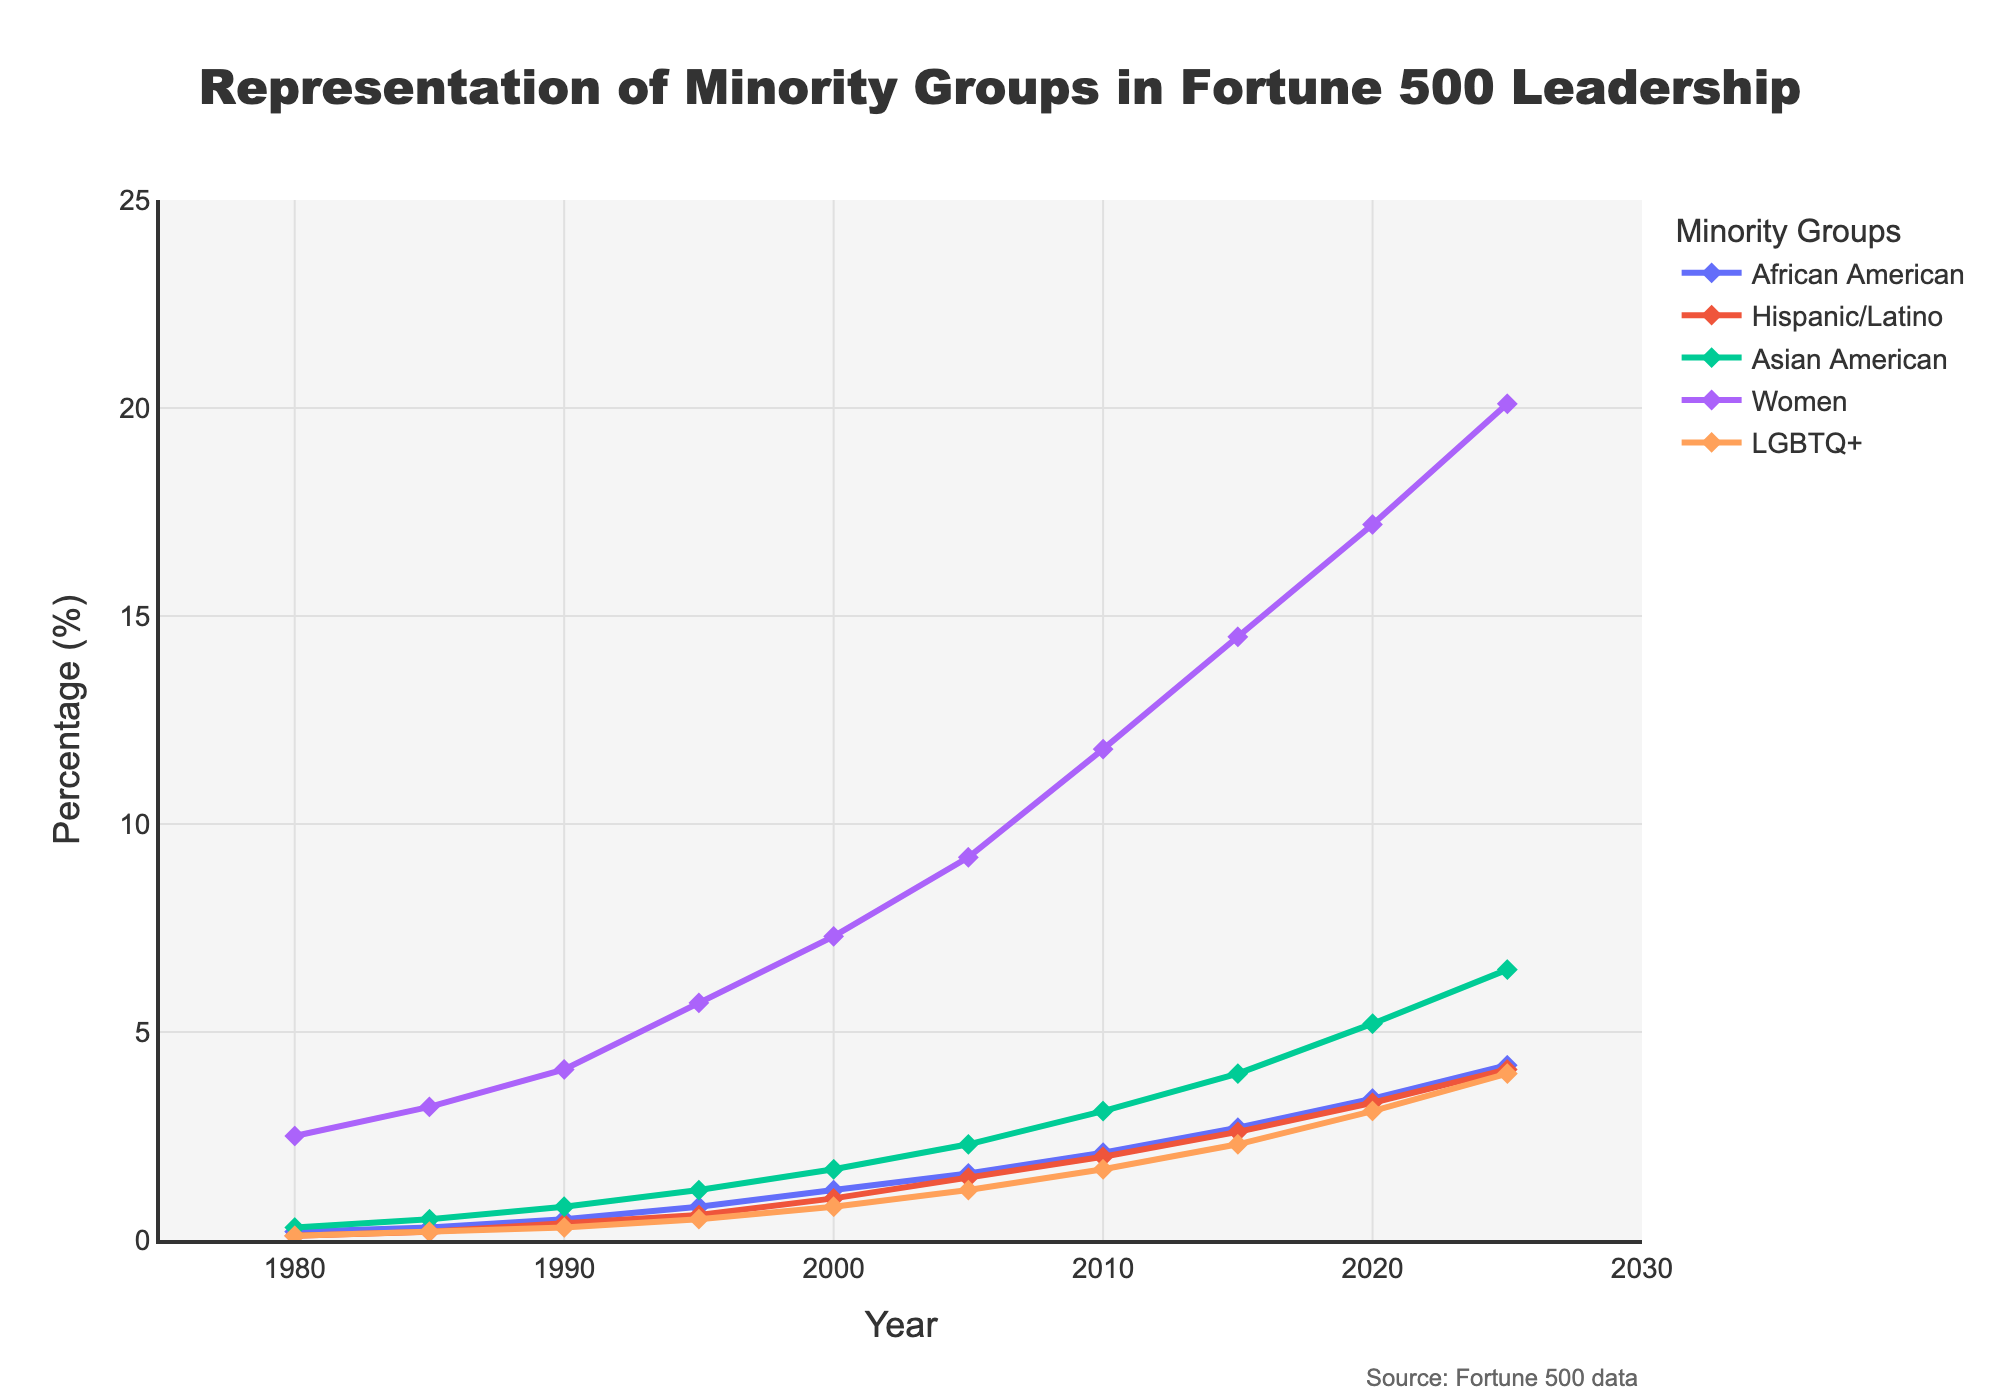What's the percentage increase in representation of African American leaders from 1980 to 2025? First, note the percentage in 1980 (0.2%) and the percentage in 2025 (4.2%). The percentage increase is calculated by the formula: ((new value - original value) / original value) * 100. So, ((4.2 - 0.2) / 0.2) * 100 = 2000%.
Answer: 2000% Which minority group had the highest representation in 2020? In 2020, the percentages for each group are: African American (3.4%), Hispanic/Latino (3.3%), Asian American (5.2%), Women (17.2%), and LGBTQ+ (3.1%). Among these, Women have the highest representation at 17.2%.
Answer: Women By how many percentage points did the representation of Hispanic/Latino leaders increase between 2000 and 2010? The percentage in 2000 is 1.0% and in 2010 is 2.0%. Subtract the 2000 value from the 2010 value to find the increase: 2.0% - 1.0% = 1.0 percentage point increase.
Answer: 1.0 What trend can be observed in the representation of LGBTQ+ leaders over the years? Observing the data for LGBTQ+ from 1980 (0.1%) to 2025 (4.0%), the trend shows a steady increase in representation over time.
Answer: Steady increase How does the representation of Asian American leaders in 2010 compare to Women leaders in 1990? In 2010, the representation of Asian American leaders is 3.1%. In 1990, the representation of Women leaders is 4.1%. Comparing these two, Women leaders in 1990 had a higher representation than Asian American leaders in 2010 by 1.0 percentage point.
Answer: Women leaders had higher representation by 1.0 percentage point Which group had the smallest increase in representation from 1980 to 2025? Looking at the initial and final values: African American (0.2% to 4.2%), Hispanic/Latino (0.1% to 4.1%), Asian American (0.3% to 6.5%), Women (2.5% to 20.1%), LGBTQ+ (0.1% to 4.0%). The smallest increase in representation is in Hispanic/Latino leaders with an increase of 4.0 percentage points.
Answer: Hispanic/Latino What is the average representation of Asian American leaders across all the years provided? Adding the values for Asian American leaders across all years: 0.3 + 0.5 + 0.8 + 1.2 + 1.7 + 2.3 + 3.1 + 4.0 + 5.2 + 6.5 = 25.6. There are 10 years of data, so the average is 25.6 / 10 = 2.56%.
Answer: 2.56% How do the trends in representation of Women and LGBTQ+ leaders compare from 2000 to 2025? From 2000 to 2025, Women leaders increase from 7.3% to 20.1%, an increase of 12.8 percentage points. LGBTQ+ leaders increase from 0.8% to 4.0%, an increase of 3.2 percentage points. Women leaders show a much more significant increase compared to LGBTQ+ leaders.
Answer: Women leaders had a larger increase What is the representation of Hispanic/Latino leaders in 2015 compared to the representation of African American leaders in 2020? In 2015, the representation of Hispanic/Latino leaders is 2.6%. In 2020, the representation of African American leaders is 3.4%. Comparing these, African American leaders in 2020 had higher representation than Hispanic/Latino leaders in 2015 by 0.8 percentage points.
Answer: African American leaders had higher representation by 0.8 percentage points 